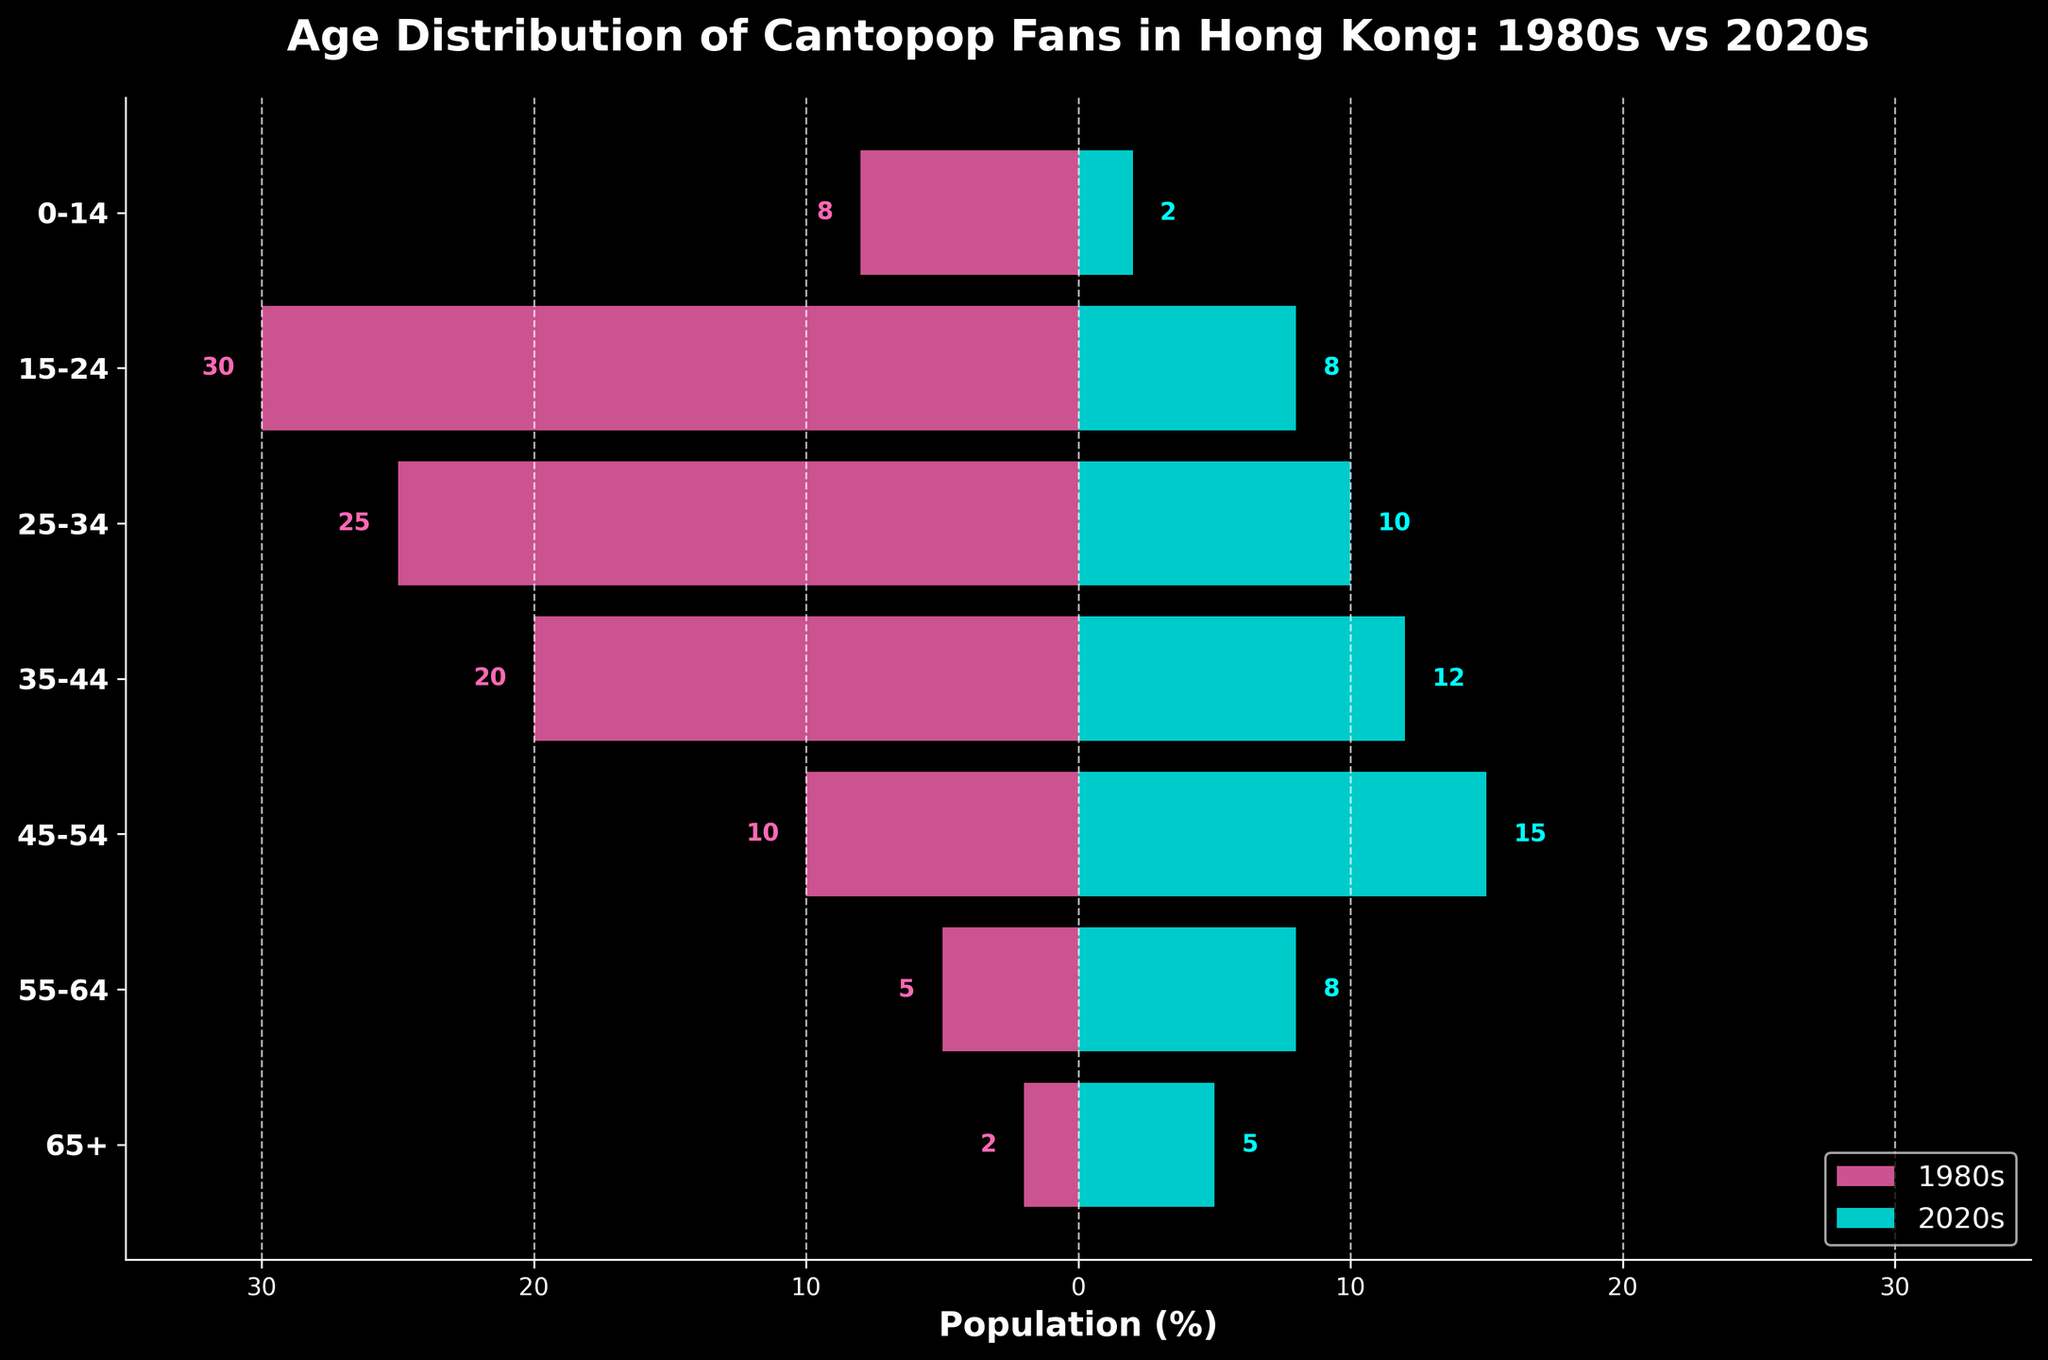What is the title of the figure? The title of the figure is textually descriptive and is located at the top of the plot. It typically summarizes the main subject of the visualization.
Answer: Age Distribution of Cantopop Fans in Hong Kong: 1980s vs 2020s Which age group had the highest percentage of Cantopop fans in the 1980s? To find this, look at the left side of the population pyramid and identify the longest bar.
Answer: 15-24 What was the percentage of Cantopop fans aged 25-34 in the 2020s? Locate the '25-34' age group on the y-axis, then find the corresponding right-side bar length.
Answer: 10% How did the percentage of Cantopop fans aged 45-54 change from the 1980s to the 2020s? Compare the bar lengths for the 45-54 age group on both sides of the pyramid. Calculate the difference between the two percentages.
Answer: Increased by 5% What was the combined percentage of Cantopop fans aged 35-44 and 45-54 in the 1980s? Add the percentage values of the '35-44' and '45-54' bars on the left side of the plot. 20 + 10 = 30.
Answer: 30% Which age group showed the most significant decline in the percentage of fans from the 1980s to the 2020s? Calculate the percentage drop for each age group by subtracting the 2020s value from the 1980s value and identify the largest decline.
Answer: 15-24 How many age groups had a higher percentage of fans in the 2020s compared to the 1980s? Compare the values of each age group between the two decades and count how many age groups have a higher value in the 2020s.
Answer: 3 Which age group had the second highest percentage of fans in the 2020s? Check the right side of the plot, identify the second longest bar.
Answer: 45-54 What were the percentages of fans aged 65+ in both the 1980s and 2020s? Locate the '65+' age group on the y-axis and find the bar lengths for both decades.
Answer: 2% (1980s), 5% (2020s) Which age group saw the smallest change in fan percentage between 1980s and 2020s? Calculate the absolute difference for each age group between the 1980s and 2020s values and identify the smallest change.
Answer: 0-14 